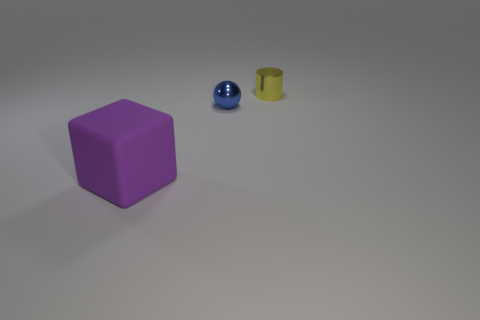Add 1 big purple objects. How many objects exist? 4 Subtract all large yellow metallic balls. Subtract all blue shiny things. How many objects are left? 2 Add 2 small yellow metal objects. How many small yellow metal objects are left? 3 Add 1 tiny yellow shiny cylinders. How many tiny yellow shiny cylinders exist? 2 Subtract 0 cyan cylinders. How many objects are left? 3 Subtract all blocks. How many objects are left? 2 